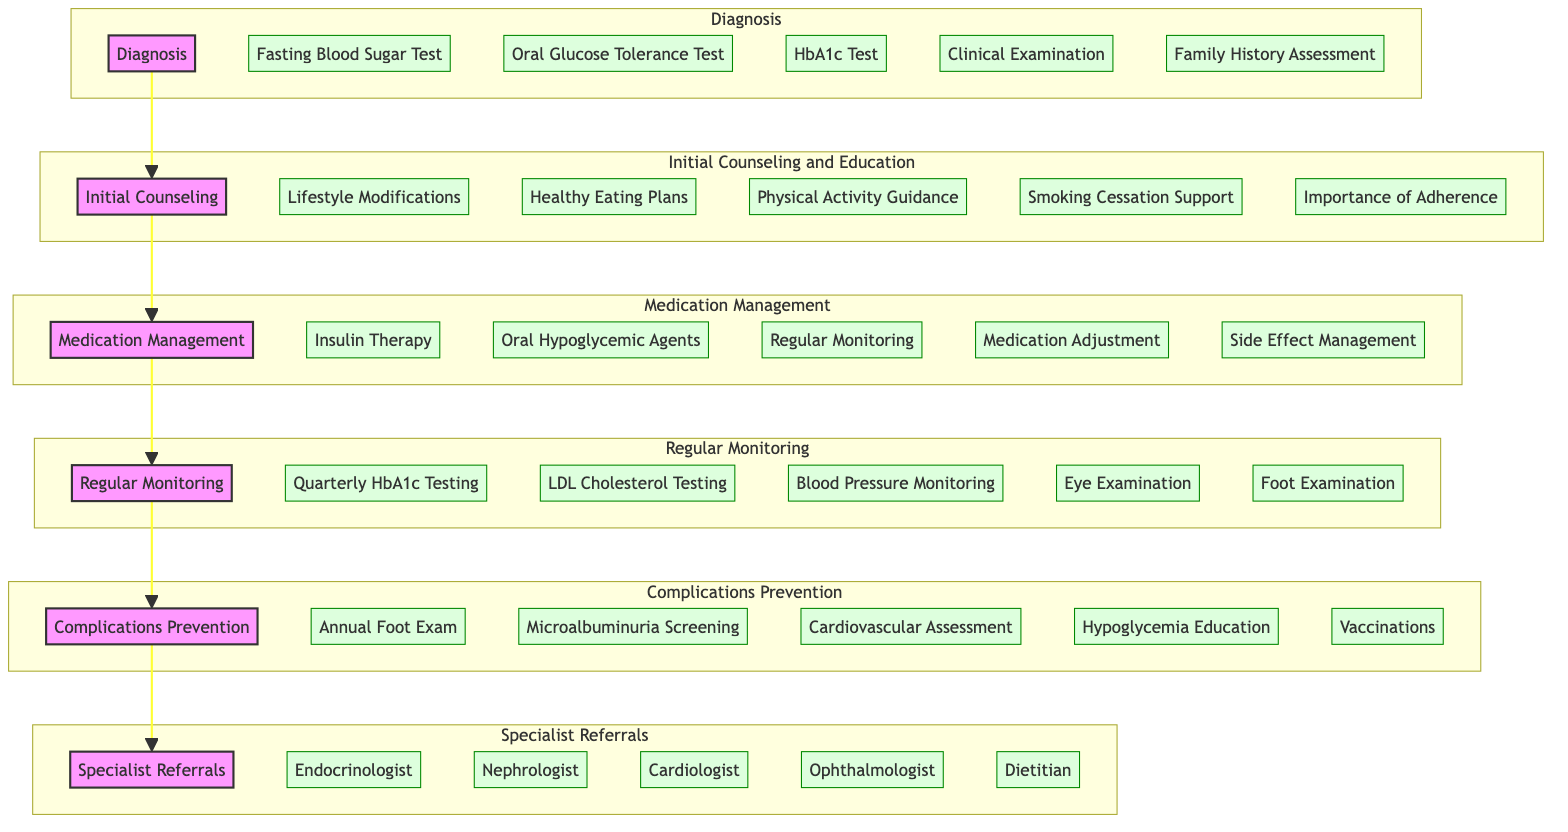What is the first stage in the clinical pathway? The diagram's flow starts with the 'Diagnosis' stage, indicating that this is the initial phase of the clinical pathway.
Answer: Diagnosis How many components are involved in the Medication Management stage? In the Medication Management stage, there are five components listed, which include Insulin Therapy, Oral Hypoglycemic Agents, Regular Monitoring, Medication Adjustment, and Side Effect Management.
Answer: 5 What follows the Regular Monitoring stage in the pathway? According to the diagram, the next stage after Regular Monitoring is Complications Prevention, establishing a sequential flow in the clinical process.
Answer: Complications Prevention Which two specialists are included in the Specialist Referrals stage? The Specialist Referrals stage includes references to several specialists, specifically the Endocrinologist and Cardiologist. This answers the question by directly identifying these two components.
Answer: Endocrinologist, Cardiologist What is the purpose of the Initial Counseling and Education stage? The Initial Counseling and Education stage's purpose is to provide foundational support through lifestyle modifications, healthy eating plans, and physical activity guidance, which are crucial for disease management.
Answer: Education and support How many total stages are listed in the clinical pathway? The diagram outlines six distinct stages total: Diagnosis, Initial Counseling and Education, Medication Management, Regular Monitoring, Complications Prevention, and Specialist Referrals, culminating in a comprehensive pathway.
Answer: 6 During which stage would a patient receive vaccinations? The component related to vaccinations occurs during the Complications Prevention stage, as it emphasizes preventive measures against potential complications for diabetes patients.
Answer: Complications Prevention What component is not part of the Regular Monitoring stage? The components listed under Regular Monitoring are Quarterly HbA1c Testing, LDL Cholesterol Testing, Blood Pressure Monitoring, Eye Examination, and Foot Examination. Any component outside these is considered not part of this stage, like Insulin Therapy.
Answer: Insulin Therapy 